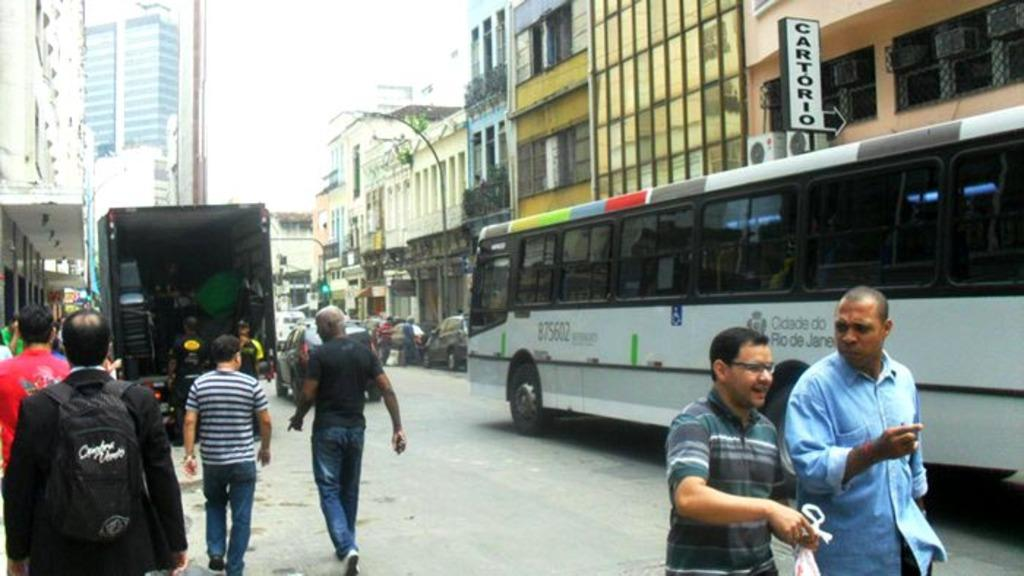<image>
Relay a brief, clear account of the picture shown. One of the signs on the building above the bus says Cartorio. 